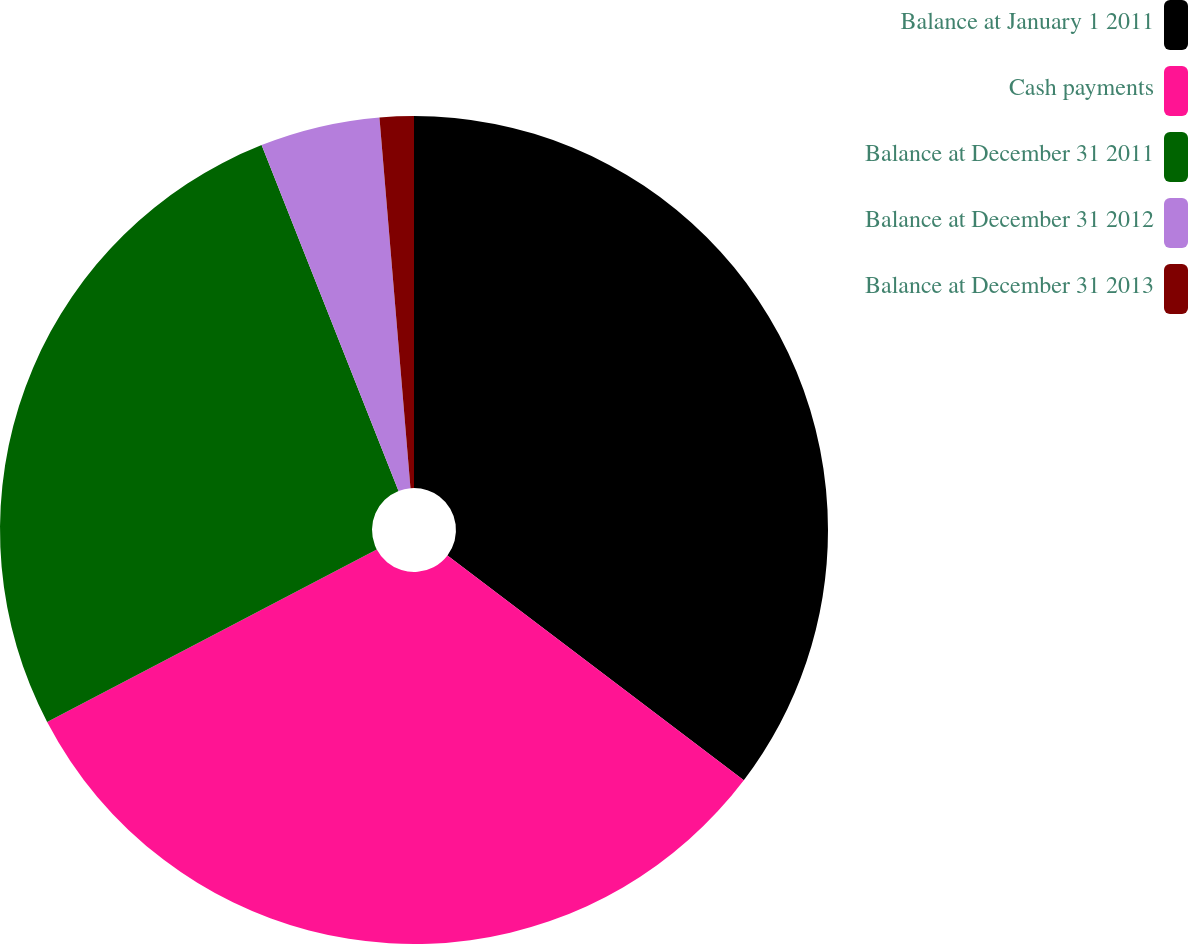<chart> <loc_0><loc_0><loc_500><loc_500><pie_chart><fcel>Balance at January 1 2011<fcel>Cash payments<fcel>Balance at December 31 2011<fcel>Balance at December 31 2012<fcel>Balance at December 31 2013<nl><fcel>35.33%<fcel>32.0%<fcel>26.67%<fcel>4.67%<fcel>1.33%<nl></chart> 